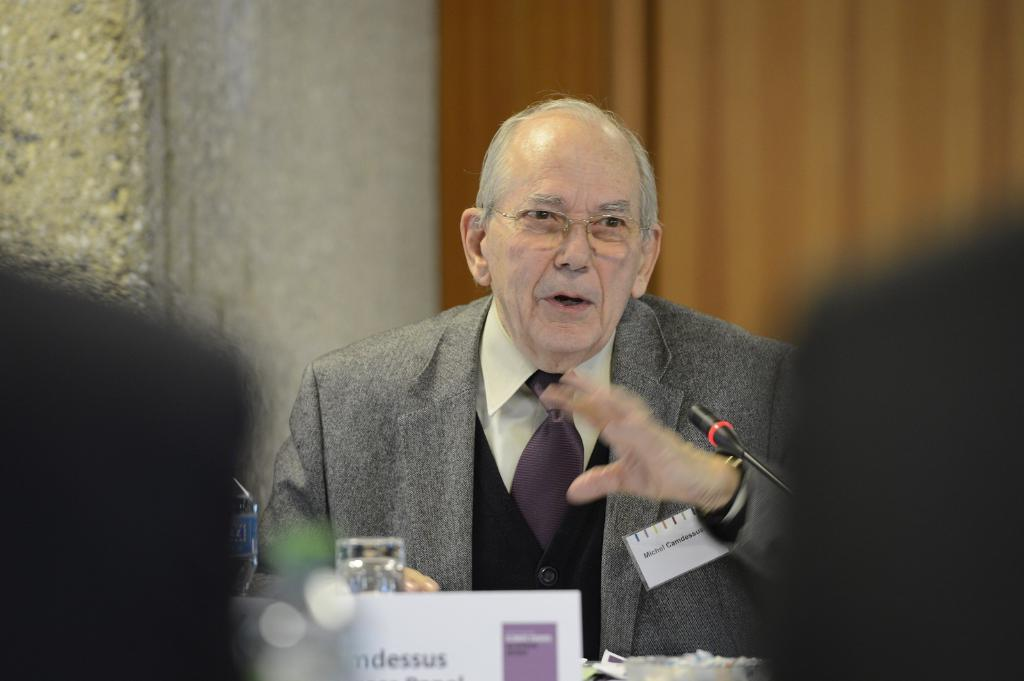<image>
Describe the image concisely. An older man named Micheal is talking, using his hands. 